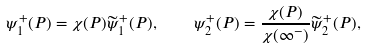Convert formula to latex. <formula><loc_0><loc_0><loc_500><loc_500>\psi _ { 1 } ^ { + } ( P ) = \chi ( P ) \widetilde { \psi } _ { 1 } ^ { + } ( P ) , \quad \psi _ { 2 } ^ { + } ( P ) = \frac { \chi ( P ) } { \chi ( \infty ^ { - } ) } \widetilde { \psi } _ { 2 } ^ { + } ( P ) ,</formula> 